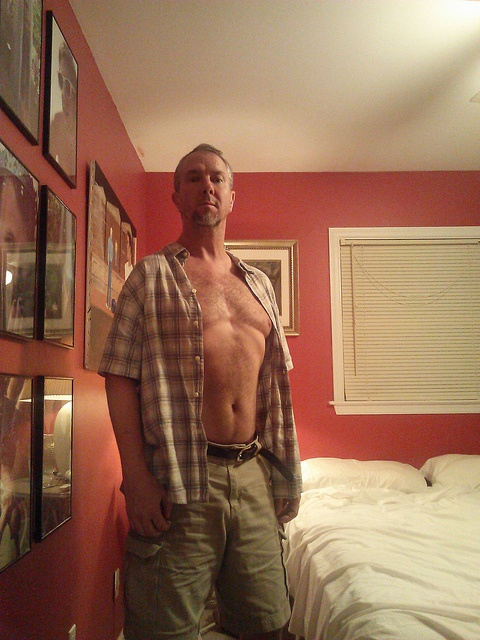Describe the objects in this image and their specific colors. I can see people in black, maroon, and brown tones and bed in black, beige, and tan tones in this image. 